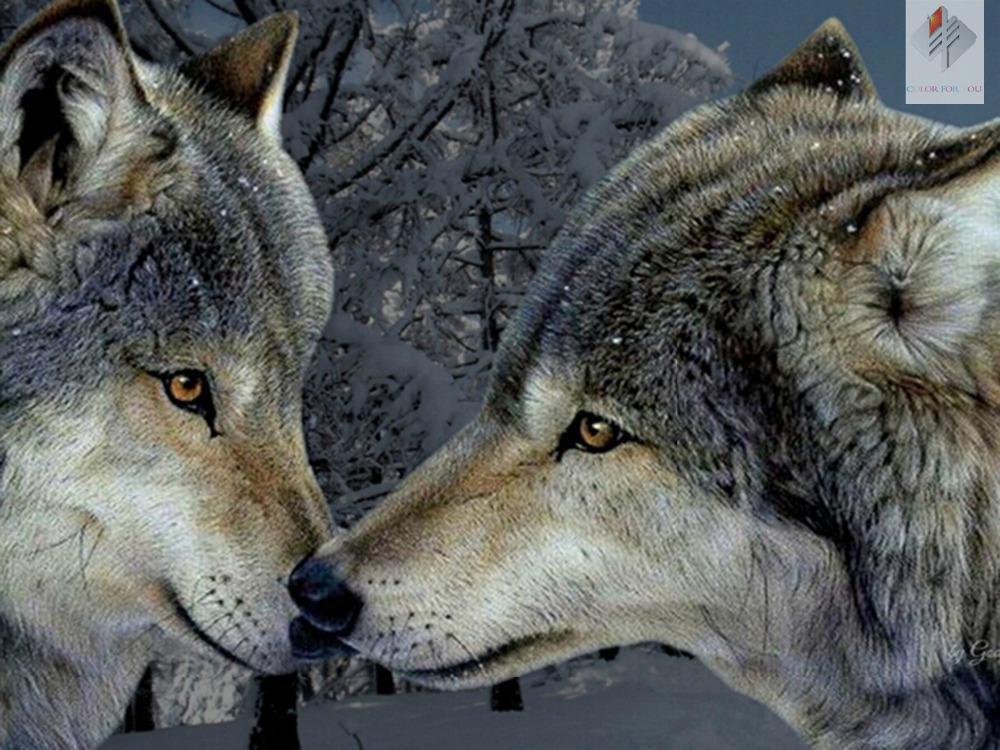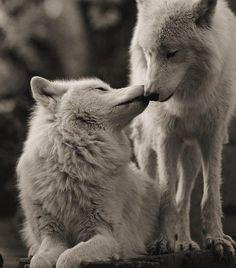The first image is the image on the left, the second image is the image on the right. Evaluate the accuracy of this statement regarding the images: "You can see a wolf's tongue.". Is it true? Answer yes or no. No. 